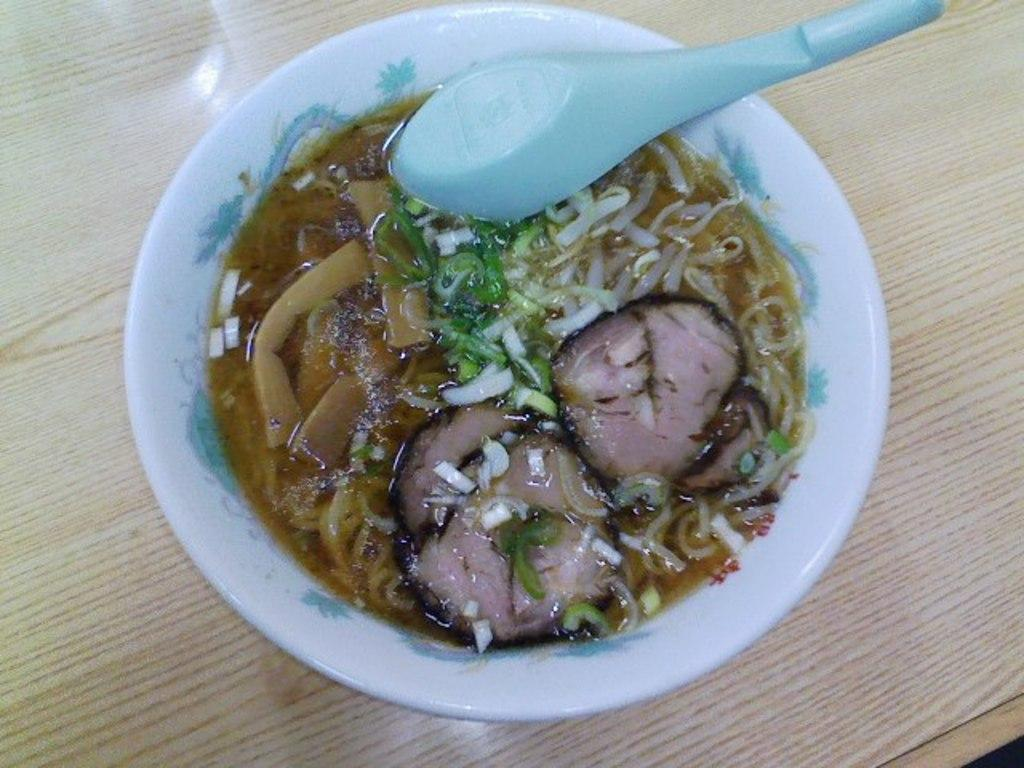What is in the bowl that is visible in the image? The bowl contains noodles and flesh. What is the color of the bowl? The bowl is white in color. What is the bowl placed on in the image? The bowl is on a wooden table. What utensil is present in the bowl? There is a spoon in the bowl. How many frogs can be seen jumping on the volcano in the image? There are no frogs or volcanoes present in the image. 